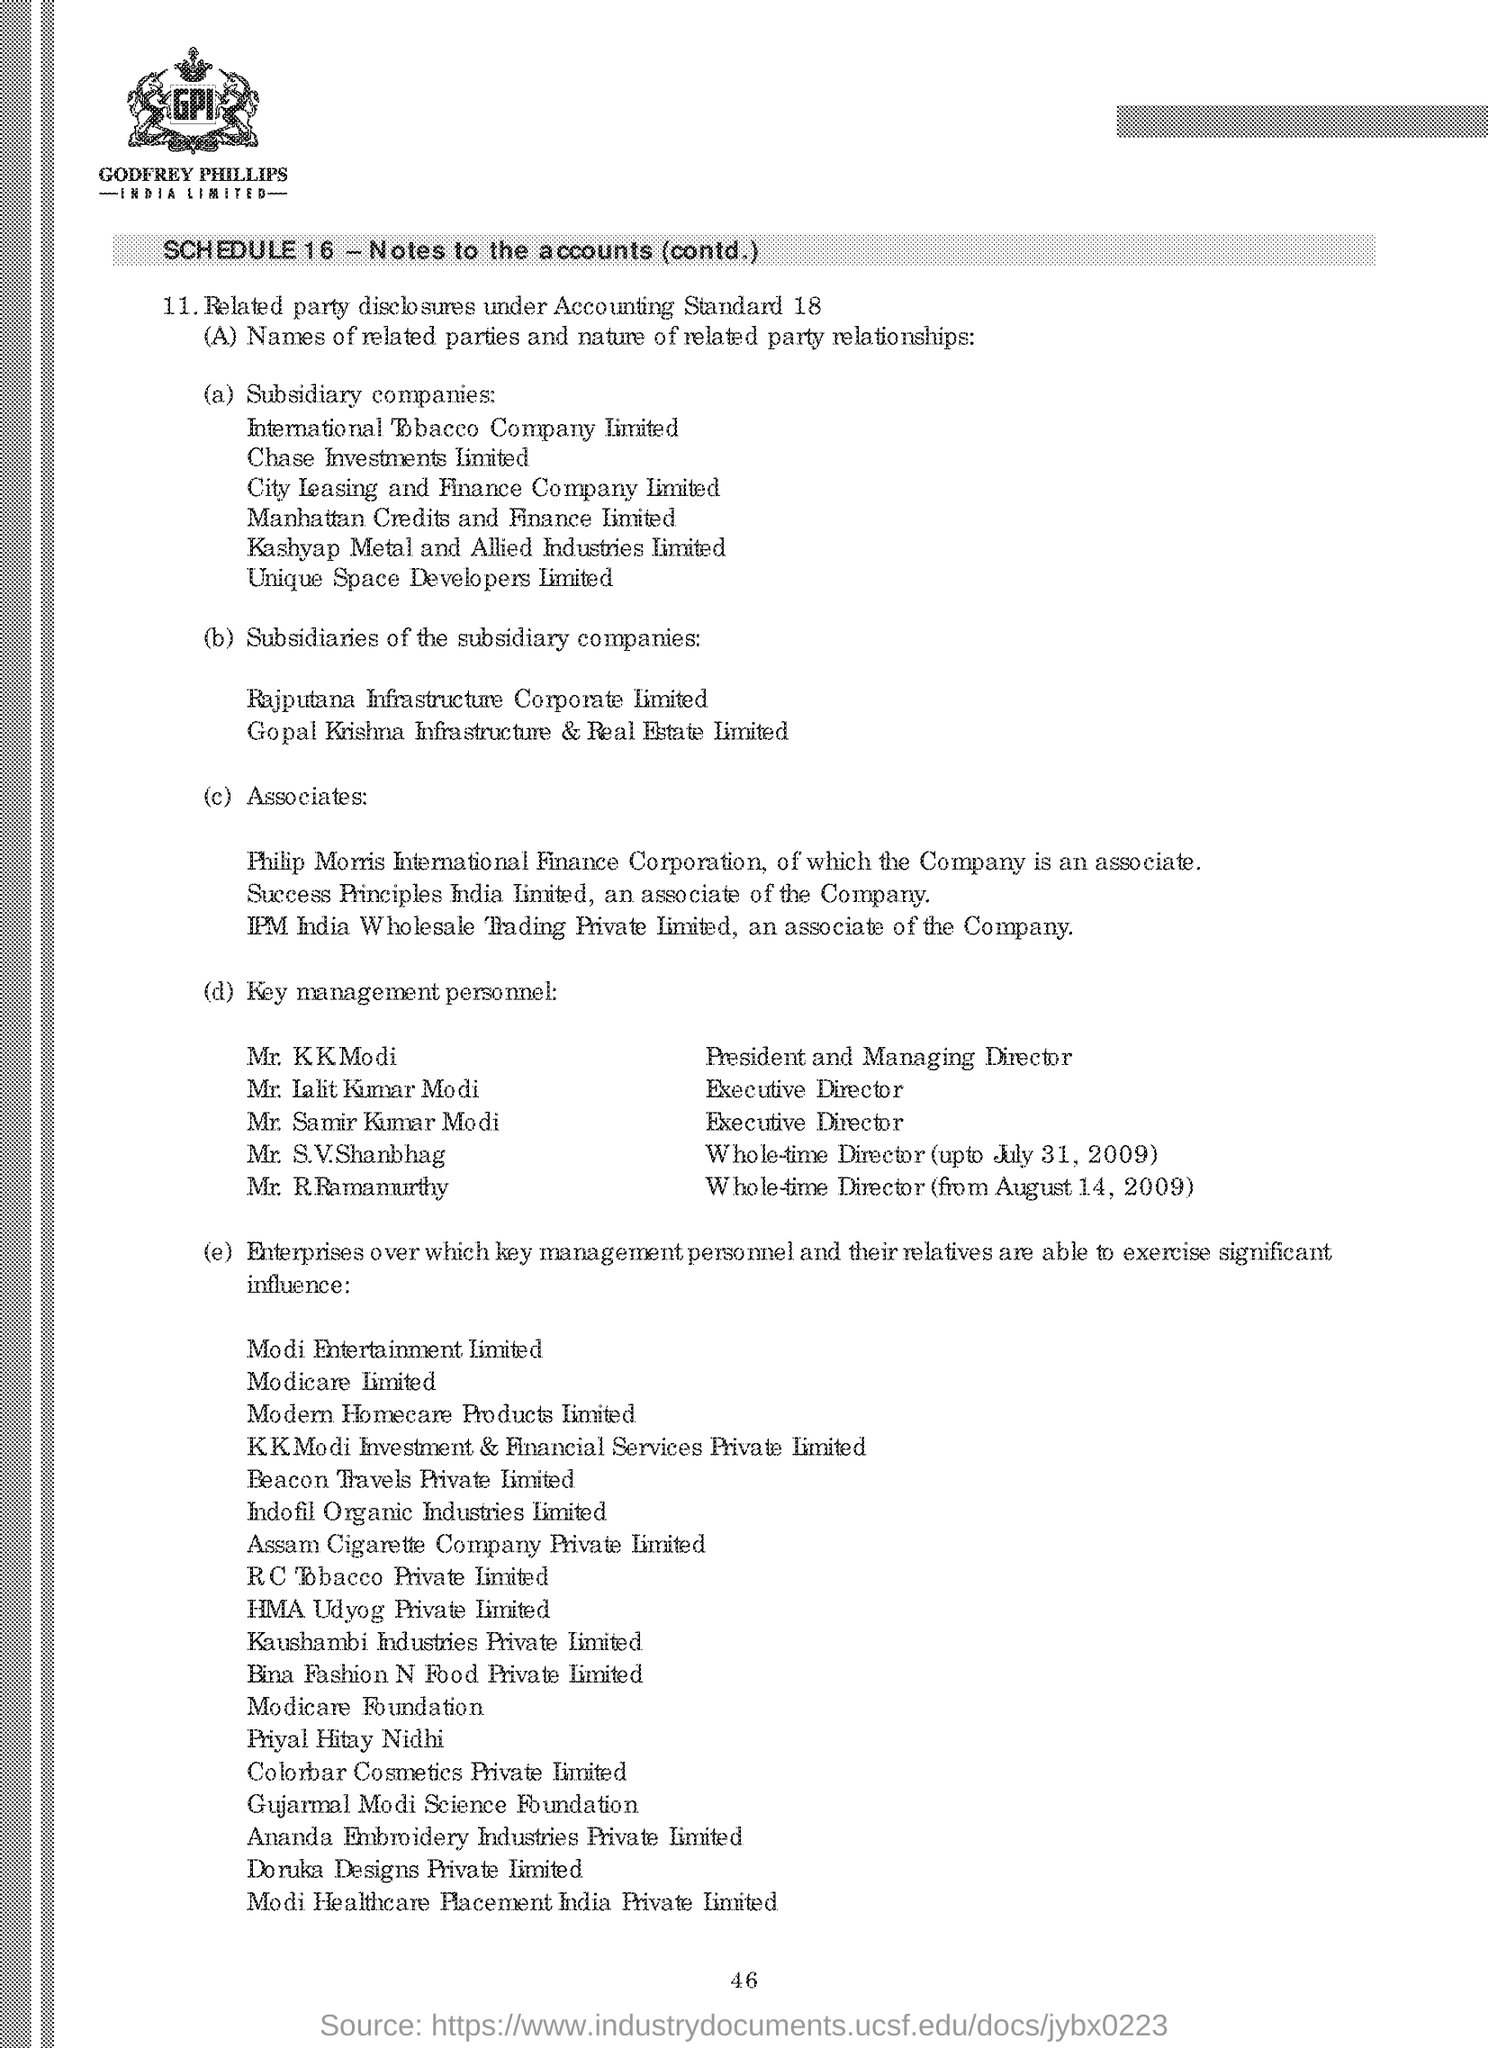Give some essential details in this illustration. The president and managing director is Mr. K K Modi, as shown in the given page. Mr. R. Ramamurthy has been the whole-time director of the company since August 14, 2009. Mr. S.V. Shanbhag was the whole-time director until July 31, 2009. 